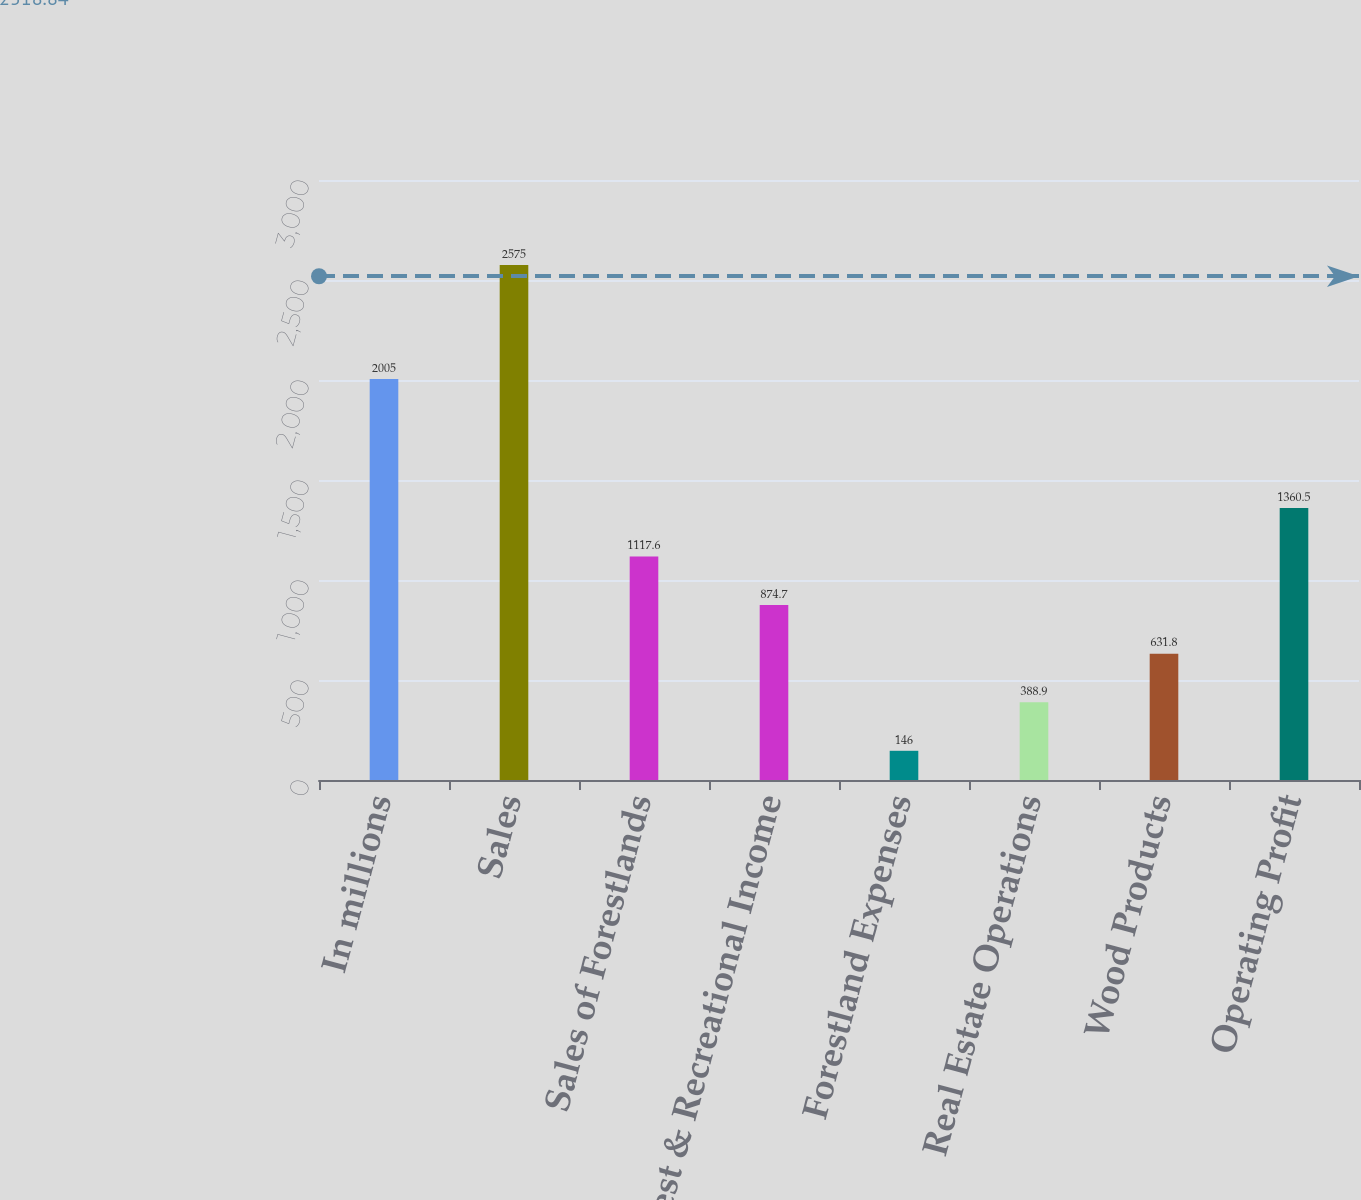Convert chart to OTSL. <chart><loc_0><loc_0><loc_500><loc_500><bar_chart><fcel>In millions<fcel>Sales<fcel>Sales of Forestlands<fcel>Harvest & Recreational Income<fcel>Forestland Expenses<fcel>Real Estate Operations<fcel>Wood Products<fcel>Operating Profit<nl><fcel>2005<fcel>2575<fcel>1117.6<fcel>874.7<fcel>146<fcel>388.9<fcel>631.8<fcel>1360.5<nl></chart> 